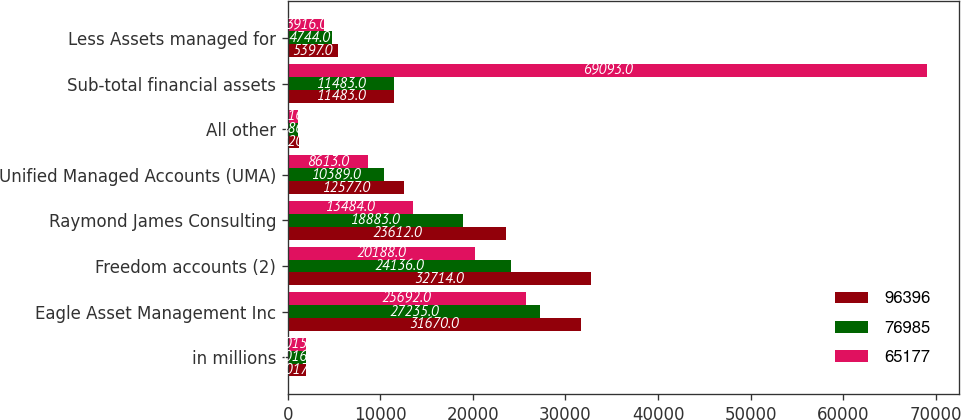<chart> <loc_0><loc_0><loc_500><loc_500><stacked_bar_chart><ecel><fcel>in millions<fcel>Eagle Asset Management Inc<fcel>Freedom accounts (2)<fcel>Raymond James Consulting<fcel>Unified Managed Accounts (UMA)<fcel>All other<fcel>Sub-total financial assets<fcel>Less Assets managed for<nl><fcel>96396<fcel>2017<fcel>31670<fcel>32714<fcel>23612<fcel>12577<fcel>1220<fcel>11483<fcel>5397<nl><fcel>76985<fcel>2016<fcel>27235<fcel>24136<fcel>18883<fcel>10389<fcel>1086<fcel>11483<fcel>4744<nl><fcel>65177<fcel>2015<fcel>25692<fcel>20188<fcel>13484<fcel>8613<fcel>1116<fcel>69093<fcel>3916<nl></chart> 